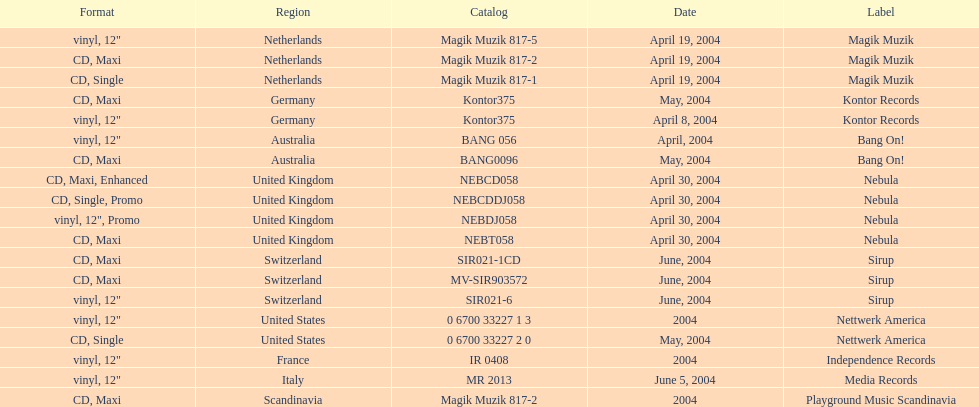What region is listed at the top? Netherlands. 